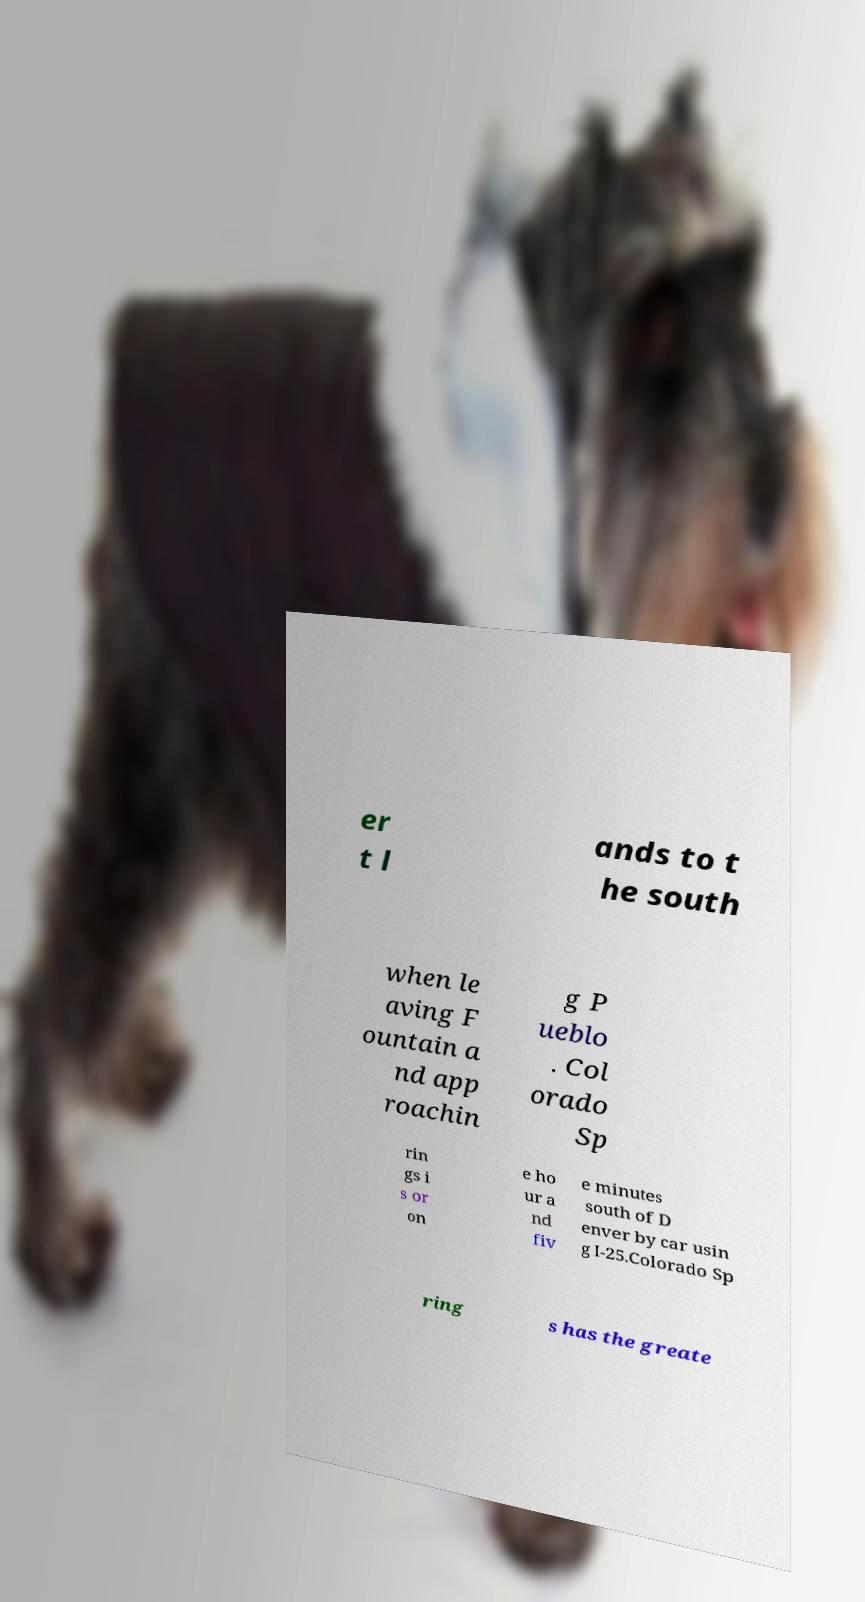Could you assist in decoding the text presented in this image and type it out clearly? er t l ands to t he south when le aving F ountain a nd app roachin g P ueblo . Col orado Sp rin gs i s or on e ho ur a nd fiv e minutes south of D enver by car usin g I-25.Colorado Sp ring s has the greate 